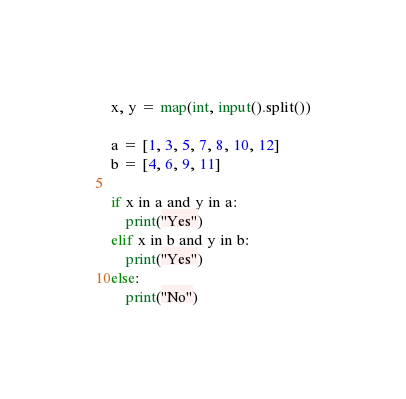<code> <loc_0><loc_0><loc_500><loc_500><_Python_>x, y = map(int, input().split())

a = [1, 3, 5, 7, 8, 10, 12]
b = [4, 6, 9, 11]

if x in a and y in a:
    print("Yes")
elif x in b and y in b:
    print("Yes")
else:
    print("No")
</code> 